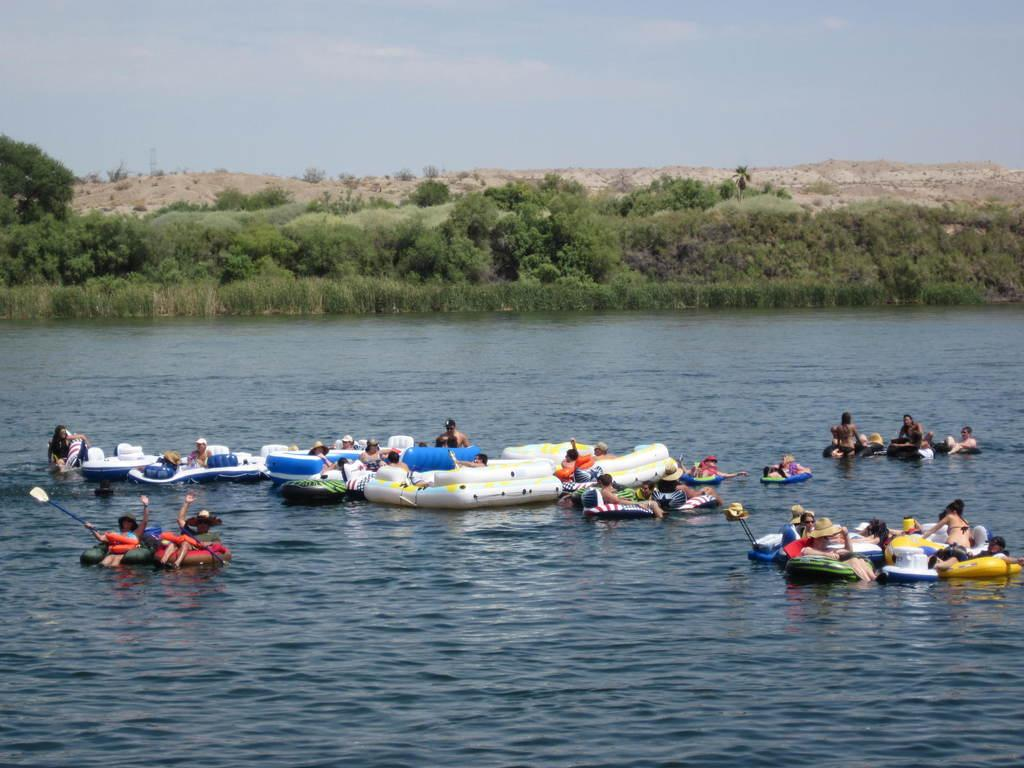What are the people in the image doing? The people in the image are on boats in the water. What can be seen in the background of the image? There are trees and plants in the background of the image. How would you describe the sky in the image? The sky in the image is cloudy. What type of twist can be seen in the hole of the boat in the image? There is no twist or hole in the boat visible in the image; it is a solid structure. 